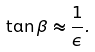Convert formula to latex. <formula><loc_0><loc_0><loc_500><loc_500>\tan \beta \approx \frac { 1 } { \epsilon } .</formula> 